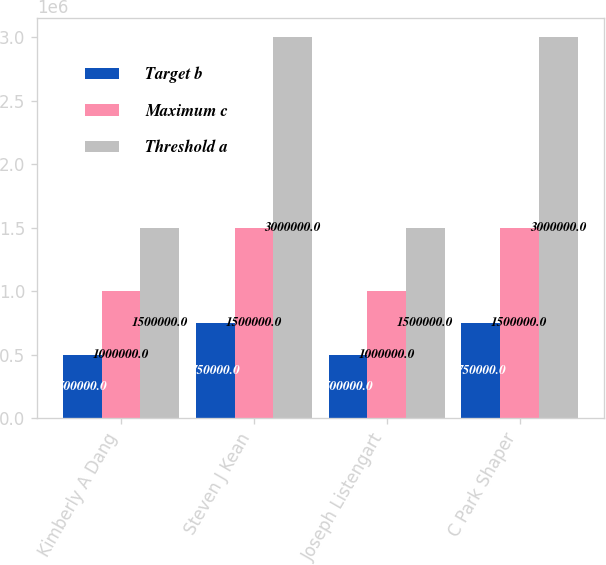Convert chart. <chart><loc_0><loc_0><loc_500><loc_500><stacked_bar_chart><ecel><fcel>Kimberly A Dang<fcel>Steven J Kean<fcel>Joseph Listengart<fcel>C Park Shaper<nl><fcel>Target b<fcel>500000<fcel>750000<fcel>500000<fcel>750000<nl><fcel>Maximum c<fcel>1e+06<fcel>1.5e+06<fcel>1e+06<fcel>1.5e+06<nl><fcel>Threshold a<fcel>1.5e+06<fcel>3e+06<fcel>1.5e+06<fcel>3e+06<nl></chart> 